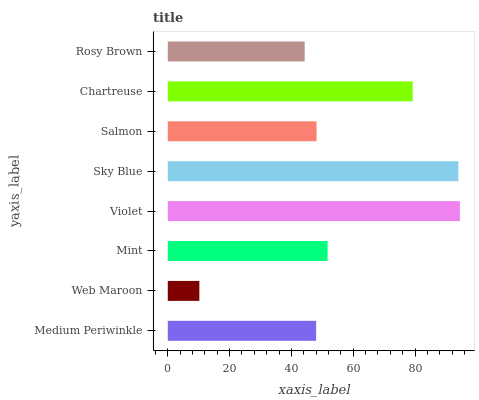Is Web Maroon the minimum?
Answer yes or no. Yes. Is Violet the maximum?
Answer yes or no. Yes. Is Mint the minimum?
Answer yes or no. No. Is Mint the maximum?
Answer yes or no. No. Is Mint greater than Web Maroon?
Answer yes or no. Yes. Is Web Maroon less than Mint?
Answer yes or no. Yes. Is Web Maroon greater than Mint?
Answer yes or no. No. Is Mint less than Web Maroon?
Answer yes or no. No. Is Mint the high median?
Answer yes or no. Yes. Is Salmon the low median?
Answer yes or no. Yes. Is Salmon the high median?
Answer yes or no. No. Is Sky Blue the low median?
Answer yes or no. No. 